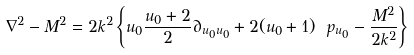<formula> <loc_0><loc_0><loc_500><loc_500>\nabla ^ { 2 } - M ^ { 2 } = 2 k ^ { 2 } \left \{ u _ { 0 } \frac { u _ { 0 } + 2 } { 2 } \partial _ { u _ { 0 } u _ { 0 } } + 2 ( u _ { 0 } + 1 ) \ p _ { u _ { 0 } } - \frac { M ^ { 2 } } { 2 k ^ { 2 } } \right \}</formula> 